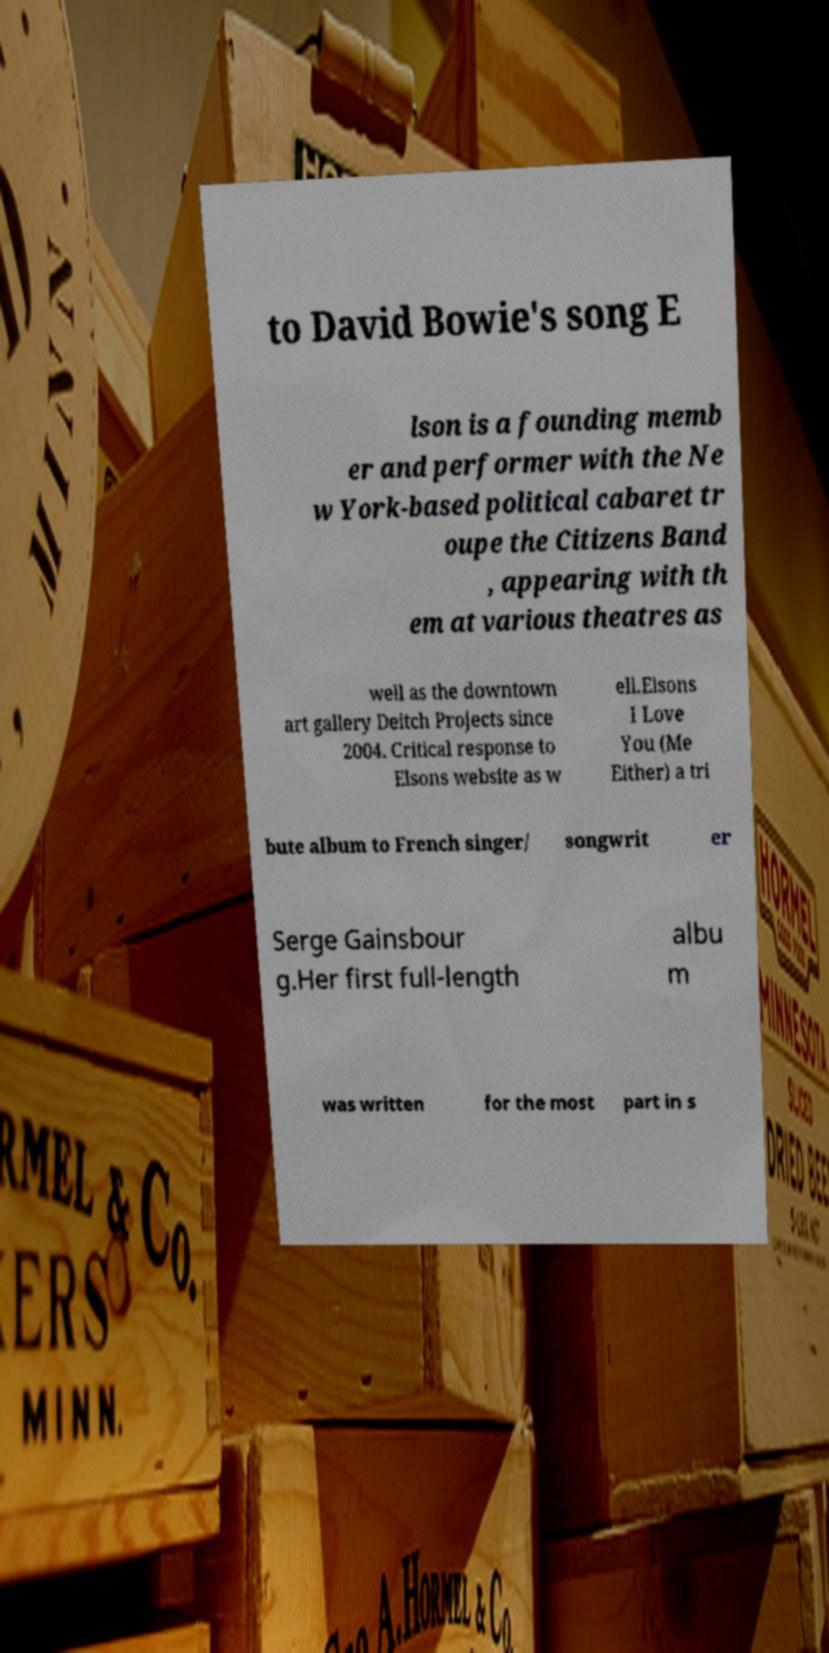For documentation purposes, I need the text within this image transcribed. Could you provide that? to David Bowie's song E lson is a founding memb er and performer with the Ne w York-based political cabaret tr oupe the Citizens Band , appearing with th em at various theatres as well as the downtown art gallery Deitch Projects since 2004. Critical response to Elsons website as w ell.Elsons I Love You (Me Either) a tri bute album to French singer/ songwrit er Serge Gainsbour g.Her first full-length albu m was written for the most part in s 